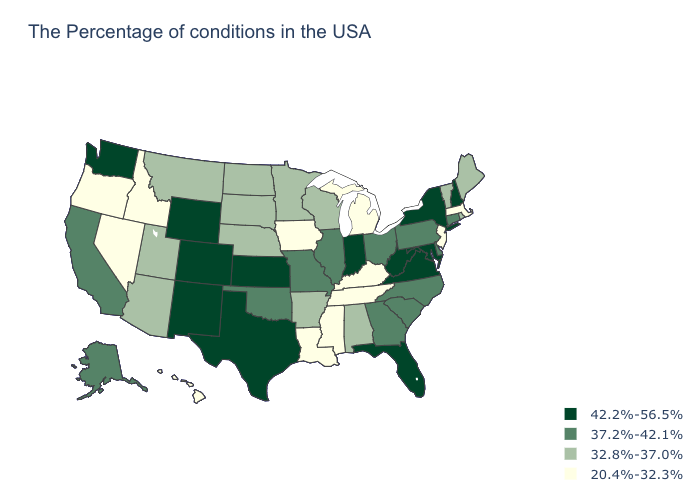What is the value of Montana?
Answer briefly. 32.8%-37.0%. Name the states that have a value in the range 32.8%-37.0%?
Keep it brief. Maine, Rhode Island, Vermont, Alabama, Wisconsin, Arkansas, Minnesota, Nebraska, South Dakota, North Dakota, Utah, Montana, Arizona. Does the first symbol in the legend represent the smallest category?
Quick response, please. No. Name the states that have a value in the range 37.2%-42.1%?
Answer briefly. Connecticut, Delaware, Pennsylvania, North Carolina, South Carolina, Ohio, Georgia, Illinois, Missouri, Oklahoma, California, Alaska. What is the value of Tennessee?
Concise answer only. 20.4%-32.3%. Name the states that have a value in the range 20.4%-32.3%?
Answer briefly. Massachusetts, New Jersey, Michigan, Kentucky, Tennessee, Mississippi, Louisiana, Iowa, Idaho, Nevada, Oregon, Hawaii. Does Iowa have the lowest value in the USA?
Short answer required. Yes. Does Missouri have a higher value than New Jersey?
Give a very brief answer. Yes. What is the value of Michigan?
Answer briefly. 20.4%-32.3%. Name the states that have a value in the range 42.2%-56.5%?
Be succinct. New Hampshire, New York, Maryland, Virginia, West Virginia, Florida, Indiana, Kansas, Texas, Wyoming, Colorado, New Mexico, Washington. Which states have the lowest value in the USA?
Answer briefly. Massachusetts, New Jersey, Michigan, Kentucky, Tennessee, Mississippi, Louisiana, Iowa, Idaho, Nevada, Oregon, Hawaii. What is the lowest value in the South?
Be succinct. 20.4%-32.3%. Among the states that border Maryland , does West Virginia have the highest value?
Keep it brief. Yes. Name the states that have a value in the range 20.4%-32.3%?
Quick response, please. Massachusetts, New Jersey, Michigan, Kentucky, Tennessee, Mississippi, Louisiana, Iowa, Idaho, Nevada, Oregon, Hawaii. How many symbols are there in the legend?
Short answer required. 4. 